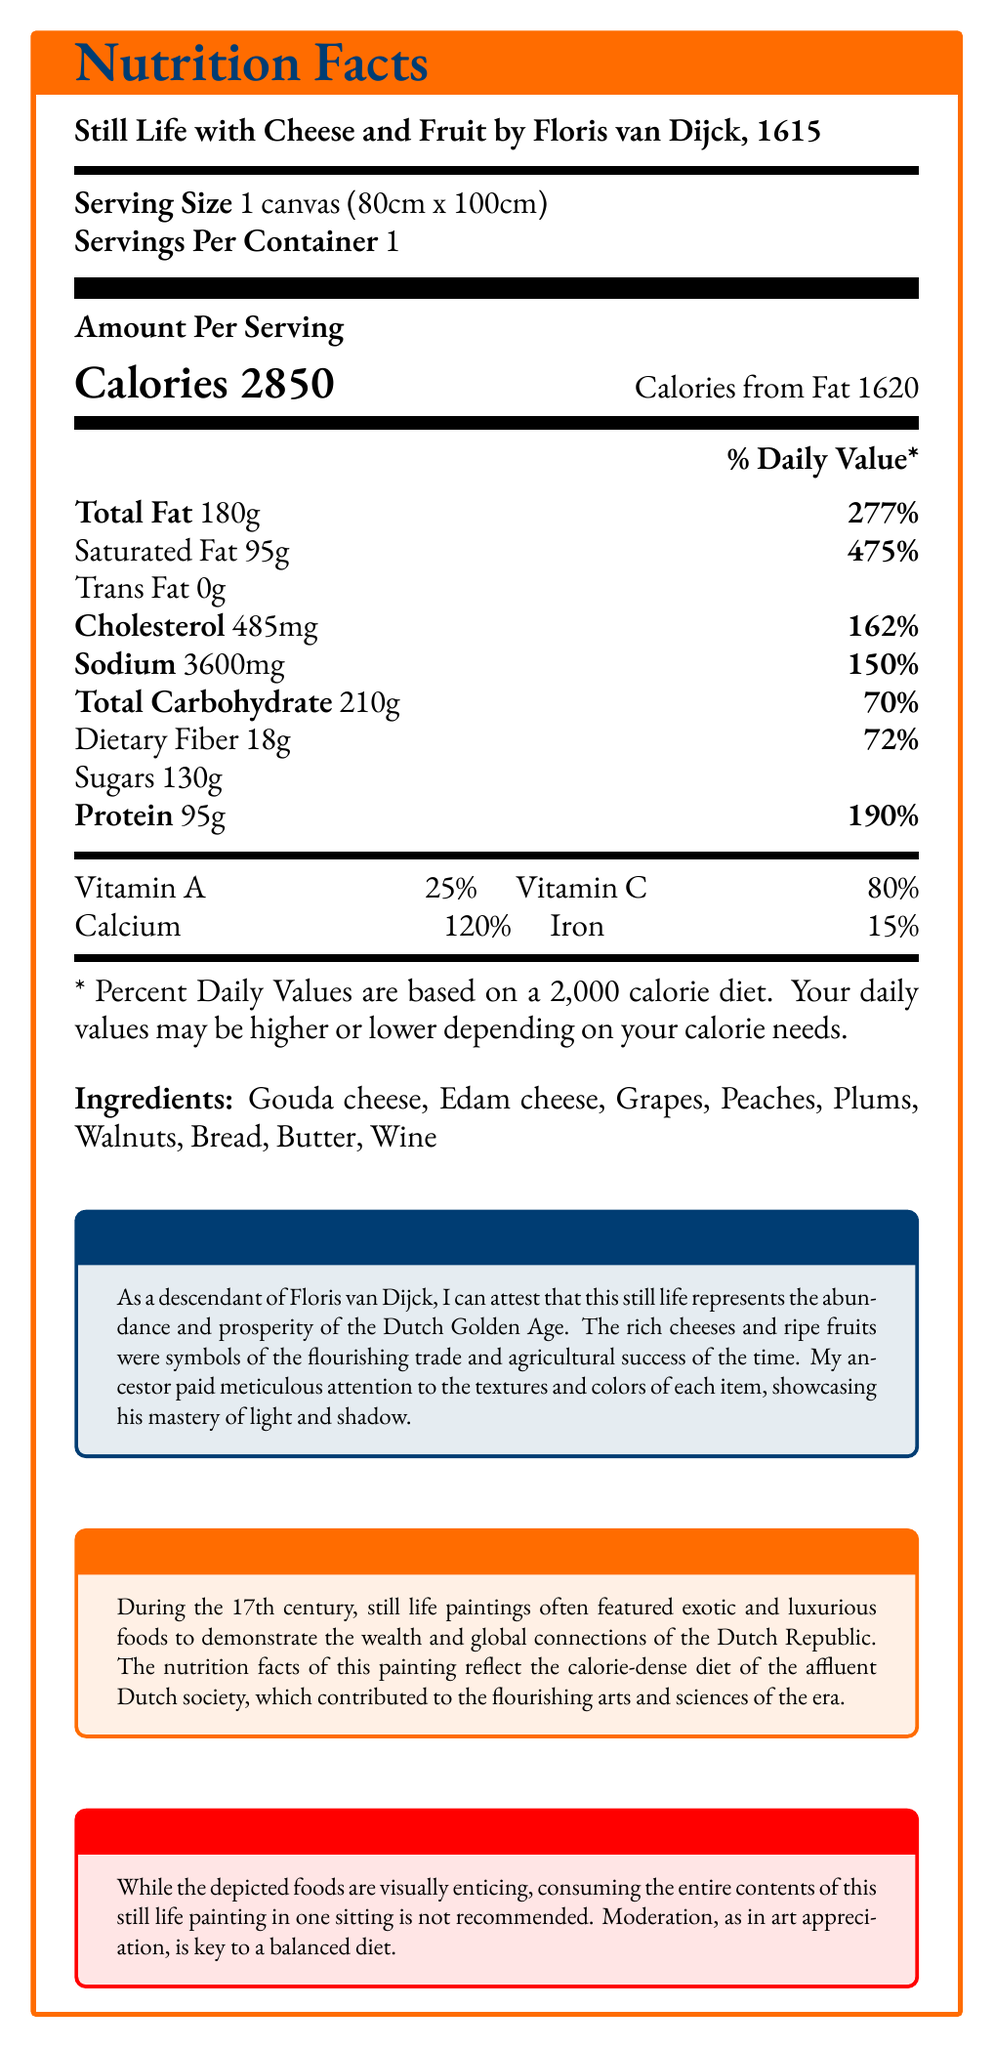what is the title of the painting? The title of the painting is clearly mentioned at the top of the document.
Answer: Still Life with Cheese and Fruit by Floris van Dijck, 1615 what is the serving size of the painting? The serving size is specified as "1 canvas (80cm x 100cm)” in the document.
Answer: 1 canvas (80cm x 100cm) how many calories are in one serving of this still life painting? The document states that there are 2850 calories per serving.
Answer: 2850 what is the daily value percentage of Saturated Fat? The daily value percentage for Saturated Fat is listed as "475%".
Answer: 475% which ingredients are included in this still life painting? The ingredient list is provided in the document.
Answer: Gouda cheese, Edam cheese, Grapes, Peaches, Plums, Walnuts, Bread, Butter, Wine how much Sodium is in one serving? The amount of Sodium is listed as 3600mg.
Answer: 3600mg what nutrient contributes the highest percentage to the daily value? The daily value for Saturated Fat is 475%, which is the highest percentage among the mentioned nutrients.
Answer: Saturated Fat which of the following is NOT an ingredient in the still life painting? A. Artichokes B. Edam Cheese C. Wine D. Walnuts The document lists Edam Cheese, Wine, and Walnuts as ingredients but does not mention Artichokes.
Answer: A. Artichokes what is the preserved daily value for Protein, Total Carbohydrate, and Cholesterol respectively? A. 150%, 70%, 162% B. 190%, 70%, 162% C. 150%, 72%, 190% D. 190%, 72%, 70% Protein has a daily value of 190%, Total Carbohydrate 70%, and Cholesterol 162%.
Answer: B. 190%, 70%, 162% are daily values for Vitamins based on a 2000-calorie diet? The document states that the Percent Daily Values are based on a 2,000 calorie diet.
Answer: Yes briefly summarize the main idea of the document. The document covers detailed nutritional information, artistic insights, and historical context about the still life painting, emphasizing its cultural and dietary significance in the Dutch Golden Age.
Answer: The document provides Nutrition Facts for the still life painting "Still Life with Cheese and Fruit" by Floris van Dijck, giving details on serving size, calorie content, and nutrient composition. It includes an artist's insight on the painting's representation of Dutch prosperity and a historical context on the luxurious diets of the 17th century Dutch society. A disclaimer advises moderation in consumption. what is the exact amount of each vitamin in the painting? The document provides the daily value percentages for vitamins but does not specify the exact amounts.
Answer: Cannot be determined what percentage of daily value does the painting provide for Calcium? The document lists the daily value for Calcium as 120%.
Answer: 120% how many grams of Trans Fat are in one serving? The Trans Fat amount per serving is listed as 0g.
Answer: 0g is it recommended to consume the entire contents of this still life painting in one sitting? The disclaimer advises against consuming the entire contents of the painting in one sitting, suggesting moderation for a balanced diet.
Answer: No which nutrient has the second highest daily value percentage after Saturated Fat? A. Cholesterol B. Total Fat C. Protein D. Vitamin C Total Fat has a daily value of 277%, which is the second highest after Saturated Fat (475%).
Answer: B. Total Fat 